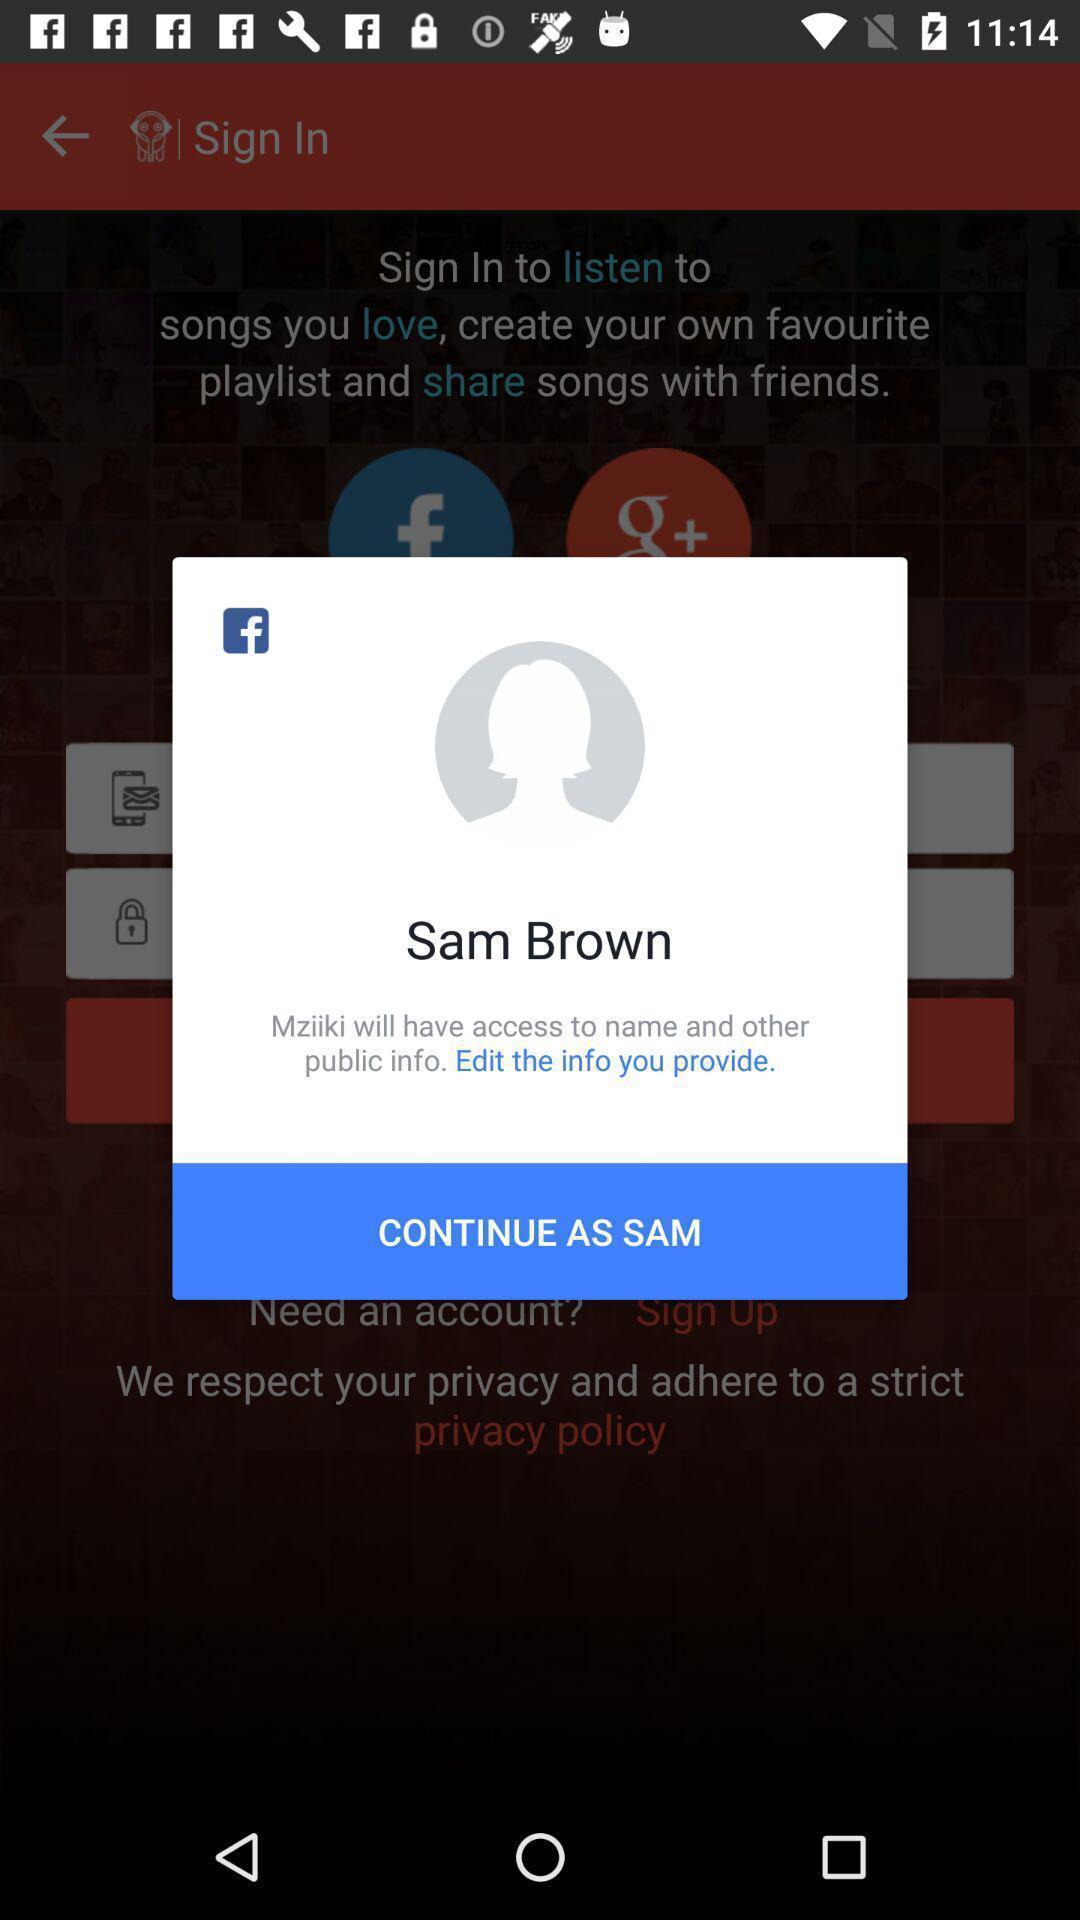Provide a textual representation of this image. Popup showing about profile and to continue. 